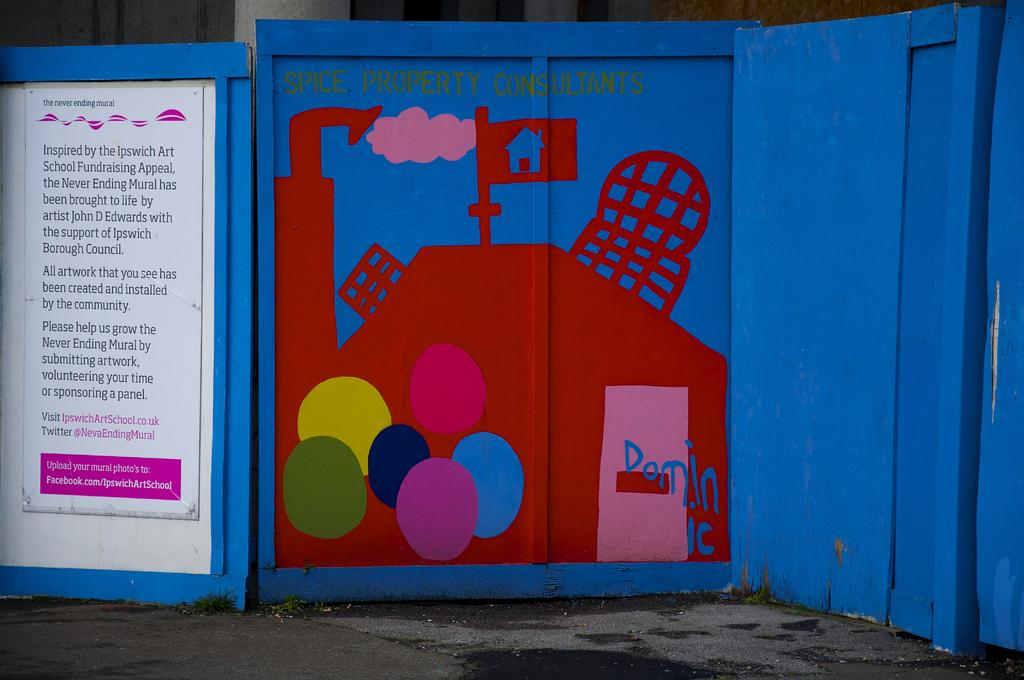<image>
Create a compact narrative representing the image presented. Drawing on a blue wall that says "Dominic" near the bottom. 